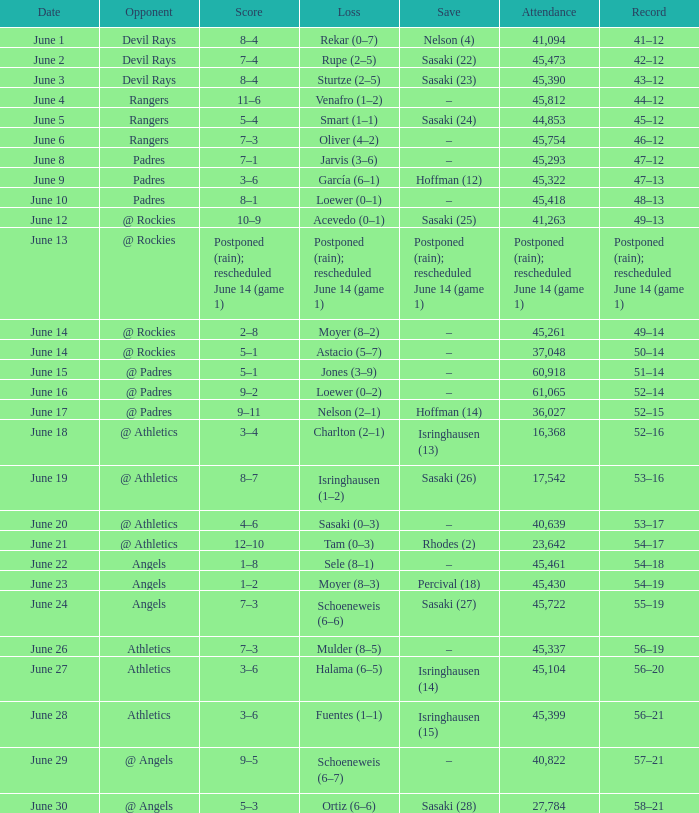Would you mind parsing the complete table? {'header': ['Date', 'Opponent', 'Score', 'Loss', 'Save', 'Attendance', 'Record'], 'rows': [['June 1', 'Devil Rays', '8–4', 'Rekar (0–7)', 'Nelson (4)', '41,094', '41–12'], ['June 2', 'Devil Rays', '7–4', 'Rupe (2–5)', 'Sasaki (22)', '45,473', '42–12'], ['June 3', 'Devil Rays', '8–4', 'Sturtze (2–5)', 'Sasaki (23)', '45,390', '43–12'], ['June 4', 'Rangers', '11–6', 'Venafro (1–2)', '–', '45,812', '44–12'], ['June 5', 'Rangers', '5–4', 'Smart (1–1)', 'Sasaki (24)', '44,853', '45–12'], ['June 6', 'Rangers', '7–3', 'Oliver (4–2)', '–', '45,754', '46–12'], ['June 8', 'Padres', '7–1', 'Jarvis (3–6)', '–', '45,293', '47–12'], ['June 9', 'Padres', '3–6', 'García (6–1)', 'Hoffman (12)', '45,322', '47–13'], ['June 10', 'Padres', '8–1', 'Loewer (0–1)', '–', '45,418', '48–13'], ['June 12', '@ Rockies', '10–9', 'Acevedo (0–1)', 'Sasaki (25)', '41,263', '49–13'], ['June 13', '@ Rockies', 'Postponed (rain); rescheduled June 14 (game 1)', 'Postponed (rain); rescheduled June 14 (game 1)', 'Postponed (rain); rescheduled June 14 (game 1)', 'Postponed (rain); rescheduled June 14 (game 1)', 'Postponed (rain); rescheduled June 14 (game 1)'], ['June 14', '@ Rockies', '2–8', 'Moyer (8–2)', '–', '45,261', '49–14'], ['June 14', '@ Rockies', '5–1', 'Astacio (5–7)', '–', '37,048', '50–14'], ['June 15', '@ Padres', '5–1', 'Jones (3–9)', '–', '60,918', '51–14'], ['June 16', '@ Padres', '9–2', 'Loewer (0–2)', '–', '61,065', '52–14'], ['June 17', '@ Padres', '9–11', 'Nelson (2–1)', 'Hoffman (14)', '36,027', '52–15'], ['June 18', '@ Athletics', '3–4', 'Charlton (2–1)', 'Isringhausen (13)', '16,368', '52–16'], ['June 19', '@ Athletics', '8–7', 'Isringhausen (1–2)', 'Sasaki (26)', '17,542', '53–16'], ['June 20', '@ Athletics', '4–6', 'Sasaki (0–3)', '–', '40,639', '53–17'], ['June 21', '@ Athletics', '12–10', 'Tam (0–3)', 'Rhodes (2)', '23,642', '54–17'], ['June 22', 'Angels', '1–8', 'Sele (8–1)', '–', '45,461', '54–18'], ['June 23', 'Angels', '1–2', 'Moyer (8–3)', 'Percival (18)', '45,430', '54–19'], ['June 24', 'Angels', '7–3', 'Schoeneweis (6–6)', 'Sasaki (27)', '45,722', '55–19'], ['June 26', 'Athletics', '7–3', 'Mulder (8–5)', '–', '45,337', '56–19'], ['June 27', 'Athletics', '3–6', 'Halama (6–5)', 'Isringhausen (14)', '45,104', '56–20'], ['June 28', 'Athletics', '3–6', 'Fuentes (1–1)', 'Isringhausen (15)', '45,399', '56–21'], ['June 29', '@ Angels', '9–5', 'Schoeneweis (6–7)', '–', '40,822', '57–21'], ['June 30', '@ Angels', '5–3', 'Ortiz (6–6)', 'Sasaki (28)', '27,784', '58–21']]} What was the tally of the mariners match when they had a record of 56–21? 3–6. 